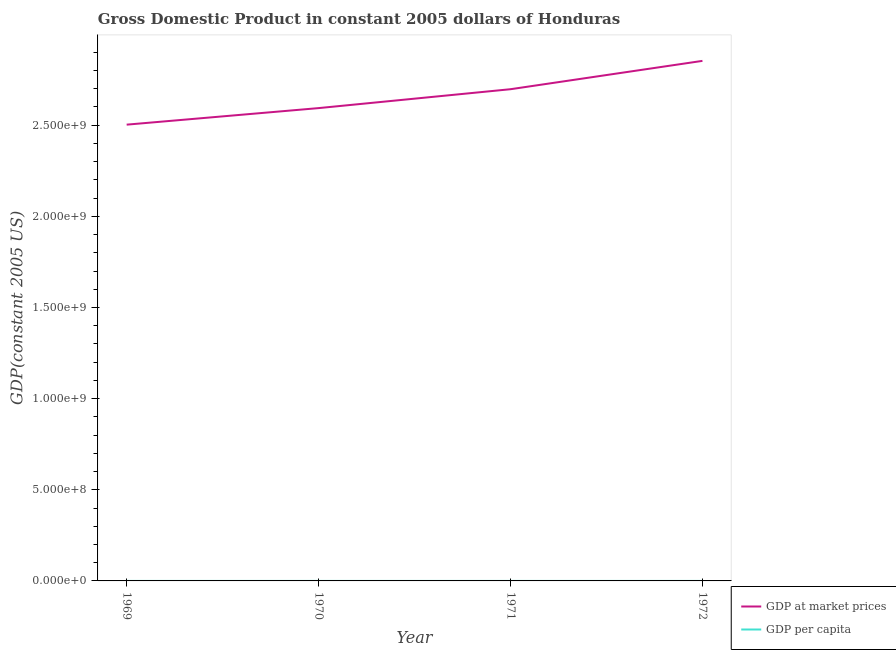How many different coloured lines are there?
Your answer should be compact. 2. Is the number of lines equal to the number of legend labels?
Offer a terse response. Yes. What is the gdp at market prices in 1970?
Make the answer very short. 2.59e+09. Across all years, what is the maximum gdp at market prices?
Make the answer very short. 2.85e+09. Across all years, what is the minimum gdp per capita?
Make the answer very short. 955.35. In which year was the gdp per capita maximum?
Offer a terse response. 1972. In which year was the gdp per capita minimum?
Ensure brevity in your answer.  1969. What is the total gdp at market prices in the graph?
Your answer should be very brief. 1.06e+1. What is the difference between the gdp at market prices in 1970 and that in 1971?
Offer a very short reply. -1.04e+08. What is the difference between the gdp at market prices in 1969 and the gdp per capita in 1970?
Your response must be concise. 2.50e+09. What is the average gdp at market prices per year?
Make the answer very short. 2.66e+09. In the year 1969, what is the difference between the gdp at market prices and gdp per capita?
Offer a terse response. 2.50e+09. In how many years, is the gdp per capita greater than 600000000 US$?
Your answer should be compact. 0. What is the ratio of the gdp at market prices in 1970 to that in 1971?
Offer a terse response. 0.96. Is the difference between the gdp at market prices in 1970 and 1972 greater than the difference between the gdp per capita in 1970 and 1972?
Your answer should be very brief. No. What is the difference between the highest and the second highest gdp per capita?
Keep it short and to the point. 27.62. What is the difference between the highest and the lowest gdp per capita?
Give a very brief answer. 47.32. Is the sum of the gdp per capita in 1969 and 1971 greater than the maximum gdp at market prices across all years?
Keep it short and to the point. No. Does the gdp per capita monotonically increase over the years?
Offer a very short reply. Yes. Is the gdp at market prices strictly greater than the gdp per capita over the years?
Make the answer very short. Yes. Is the gdp at market prices strictly less than the gdp per capita over the years?
Provide a short and direct response. No. How many lines are there?
Your answer should be very brief. 2. How many years are there in the graph?
Your response must be concise. 4. Does the graph contain any zero values?
Your answer should be compact. No. Does the graph contain grids?
Provide a succinct answer. No. How are the legend labels stacked?
Keep it short and to the point. Vertical. What is the title of the graph?
Ensure brevity in your answer.  Gross Domestic Product in constant 2005 dollars of Honduras. Does "Constant 2005 US$" appear as one of the legend labels in the graph?
Keep it short and to the point. No. What is the label or title of the X-axis?
Provide a short and direct response. Year. What is the label or title of the Y-axis?
Give a very brief answer. GDP(constant 2005 US). What is the GDP(constant 2005 US) of GDP at market prices in 1969?
Make the answer very short. 2.50e+09. What is the GDP(constant 2005 US) in GDP per capita in 1969?
Offer a terse response. 955.35. What is the GDP(constant 2005 US) in GDP at market prices in 1970?
Offer a terse response. 2.59e+09. What is the GDP(constant 2005 US) in GDP per capita in 1970?
Your answer should be very brief. 963.77. What is the GDP(constant 2005 US) of GDP at market prices in 1971?
Your response must be concise. 2.70e+09. What is the GDP(constant 2005 US) of GDP per capita in 1971?
Offer a terse response. 975.06. What is the GDP(constant 2005 US) of GDP at market prices in 1972?
Your answer should be very brief. 2.85e+09. What is the GDP(constant 2005 US) of GDP per capita in 1972?
Offer a terse response. 1002.68. Across all years, what is the maximum GDP(constant 2005 US) of GDP at market prices?
Your answer should be compact. 2.85e+09. Across all years, what is the maximum GDP(constant 2005 US) in GDP per capita?
Offer a terse response. 1002.68. Across all years, what is the minimum GDP(constant 2005 US) in GDP at market prices?
Your response must be concise. 2.50e+09. Across all years, what is the minimum GDP(constant 2005 US) of GDP per capita?
Offer a very short reply. 955.35. What is the total GDP(constant 2005 US) in GDP at market prices in the graph?
Your response must be concise. 1.06e+1. What is the total GDP(constant 2005 US) of GDP per capita in the graph?
Offer a very short reply. 3896.86. What is the difference between the GDP(constant 2005 US) in GDP at market prices in 1969 and that in 1970?
Your response must be concise. -9.08e+07. What is the difference between the GDP(constant 2005 US) in GDP per capita in 1969 and that in 1970?
Give a very brief answer. -8.42. What is the difference between the GDP(constant 2005 US) in GDP at market prices in 1969 and that in 1971?
Offer a terse response. -1.94e+08. What is the difference between the GDP(constant 2005 US) in GDP per capita in 1969 and that in 1971?
Offer a very short reply. -19.7. What is the difference between the GDP(constant 2005 US) in GDP at market prices in 1969 and that in 1972?
Your answer should be compact. -3.50e+08. What is the difference between the GDP(constant 2005 US) in GDP per capita in 1969 and that in 1972?
Provide a succinct answer. -47.32. What is the difference between the GDP(constant 2005 US) in GDP at market prices in 1970 and that in 1971?
Give a very brief answer. -1.04e+08. What is the difference between the GDP(constant 2005 US) in GDP per capita in 1970 and that in 1971?
Provide a short and direct response. -11.28. What is the difference between the GDP(constant 2005 US) in GDP at market prices in 1970 and that in 1972?
Provide a short and direct response. -2.59e+08. What is the difference between the GDP(constant 2005 US) in GDP per capita in 1970 and that in 1972?
Give a very brief answer. -38.9. What is the difference between the GDP(constant 2005 US) in GDP at market prices in 1971 and that in 1972?
Offer a terse response. -1.55e+08. What is the difference between the GDP(constant 2005 US) of GDP per capita in 1971 and that in 1972?
Give a very brief answer. -27.62. What is the difference between the GDP(constant 2005 US) in GDP at market prices in 1969 and the GDP(constant 2005 US) in GDP per capita in 1970?
Your answer should be compact. 2.50e+09. What is the difference between the GDP(constant 2005 US) in GDP at market prices in 1969 and the GDP(constant 2005 US) in GDP per capita in 1971?
Give a very brief answer. 2.50e+09. What is the difference between the GDP(constant 2005 US) in GDP at market prices in 1969 and the GDP(constant 2005 US) in GDP per capita in 1972?
Offer a very short reply. 2.50e+09. What is the difference between the GDP(constant 2005 US) of GDP at market prices in 1970 and the GDP(constant 2005 US) of GDP per capita in 1971?
Keep it short and to the point. 2.59e+09. What is the difference between the GDP(constant 2005 US) in GDP at market prices in 1970 and the GDP(constant 2005 US) in GDP per capita in 1972?
Offer a very short reply. 2.59e+09. What is the difference between the GDP(constant 2005 US) in GDP at market prices in 1971 and the GDP(constant 2005 US) in GDP per capita in 1972?
Your answer should be compact. 2.70e+09. What is the average GDP(constant 2005 US) of GDP at market prices per year?
Provide a short and direct response. 2.66e+09. What is the average GDP(constant 2005 US) of GDP per capita per year?
Your answer should be compact. 974.21. In the year 1969, what is the difference between the GDP(constant 2005 US) in GDP at market prices and GDP(constant 2005 US) in GDP per capita?
Offer a very short reply. 2.50e+09. In the year 1970, what is the difference between the GDP(constant 2005 US) of GDP at market prices and GDP(constant 2005 US) of GDP per capita?
Offer a terse response. 2.59e+09. In the year 1971, what is the difference between the GDP(constant 2005 US) in GDP at market prices and GDP(constant 2005 US) in GDP per capita?
Give a very brief answer. 2.70e+09. In the year 1972, what is the difference between the GDP(constant 2005 US) in GDP at market prices and GDP(constant 2005 US) in GDP per capita?
Provide a short and direct response. 2.85e+09. What is the ratio of the GDP(constant 2005 US) in GDP at market prices in 1969 to that in 1971?
Offer a terse response. 0.93. What is the ratio of the GDP(constant 2005 US) in GDP per capita in 1969 to that in 1971?
Offer a terse response. 0.98. What is the ratio of the GDP(constant 2005 US) of GDP at market prices in 1969 to that in 1972?
Ensure brevity in your answer.  0.88. What is the ratio of the GDP(constant 2005 US) in GDP per capita in 1969 to that in 1972?
Your answer should be very brief. 0.95. What is the ratio of the GDP(constant 2005 US) in GDP at market prices in 1970 to that in 1971?
Provide a succinct answer. 0.96. What is the ratio of the GDP(constant 2005 US) in GDP per capita in 1970 to that in 1971?
Provide a short and direct response. 0.99. What is the ratio of the GDP(constant 2005 US) in GDP at market prices in 1970 to that in 1972?
Offer a terse response. 0.91. What is the ratio of the GDP(constant 2005 US) of GDP per capita in 1970 to that in 1972?
Make the answer very short. 0.96. What is the ratio of the GDP(constant 2005 US) of GDP at market prices in 1971 to that in 1972?
Give a very brief answer. 0.95. What is the ratio of the GDP(constant 2005 US) of GDP per capita in 1971 to that in 1972?
Make the answer very short. 0.97. What is the difference between the highest and the second highest GDP(constant 2005 US) of GDP at market prices?
Ensure brevity in your answer.  1.55e+08. What is the difference between the highest and the second highest GDP(constant 2005 US) of GDP per capita?
Make the answer very short. 27.62. What is the difference between the highest and the lowest GDP(constant 2005 US) in GDP at market prices?
Your answer should be compact. 3.50e+08. What is the difference between the highest and the lowest GDP(constant 2005 US) in GDP per capita?
Your answer should be compact. 47.32. 